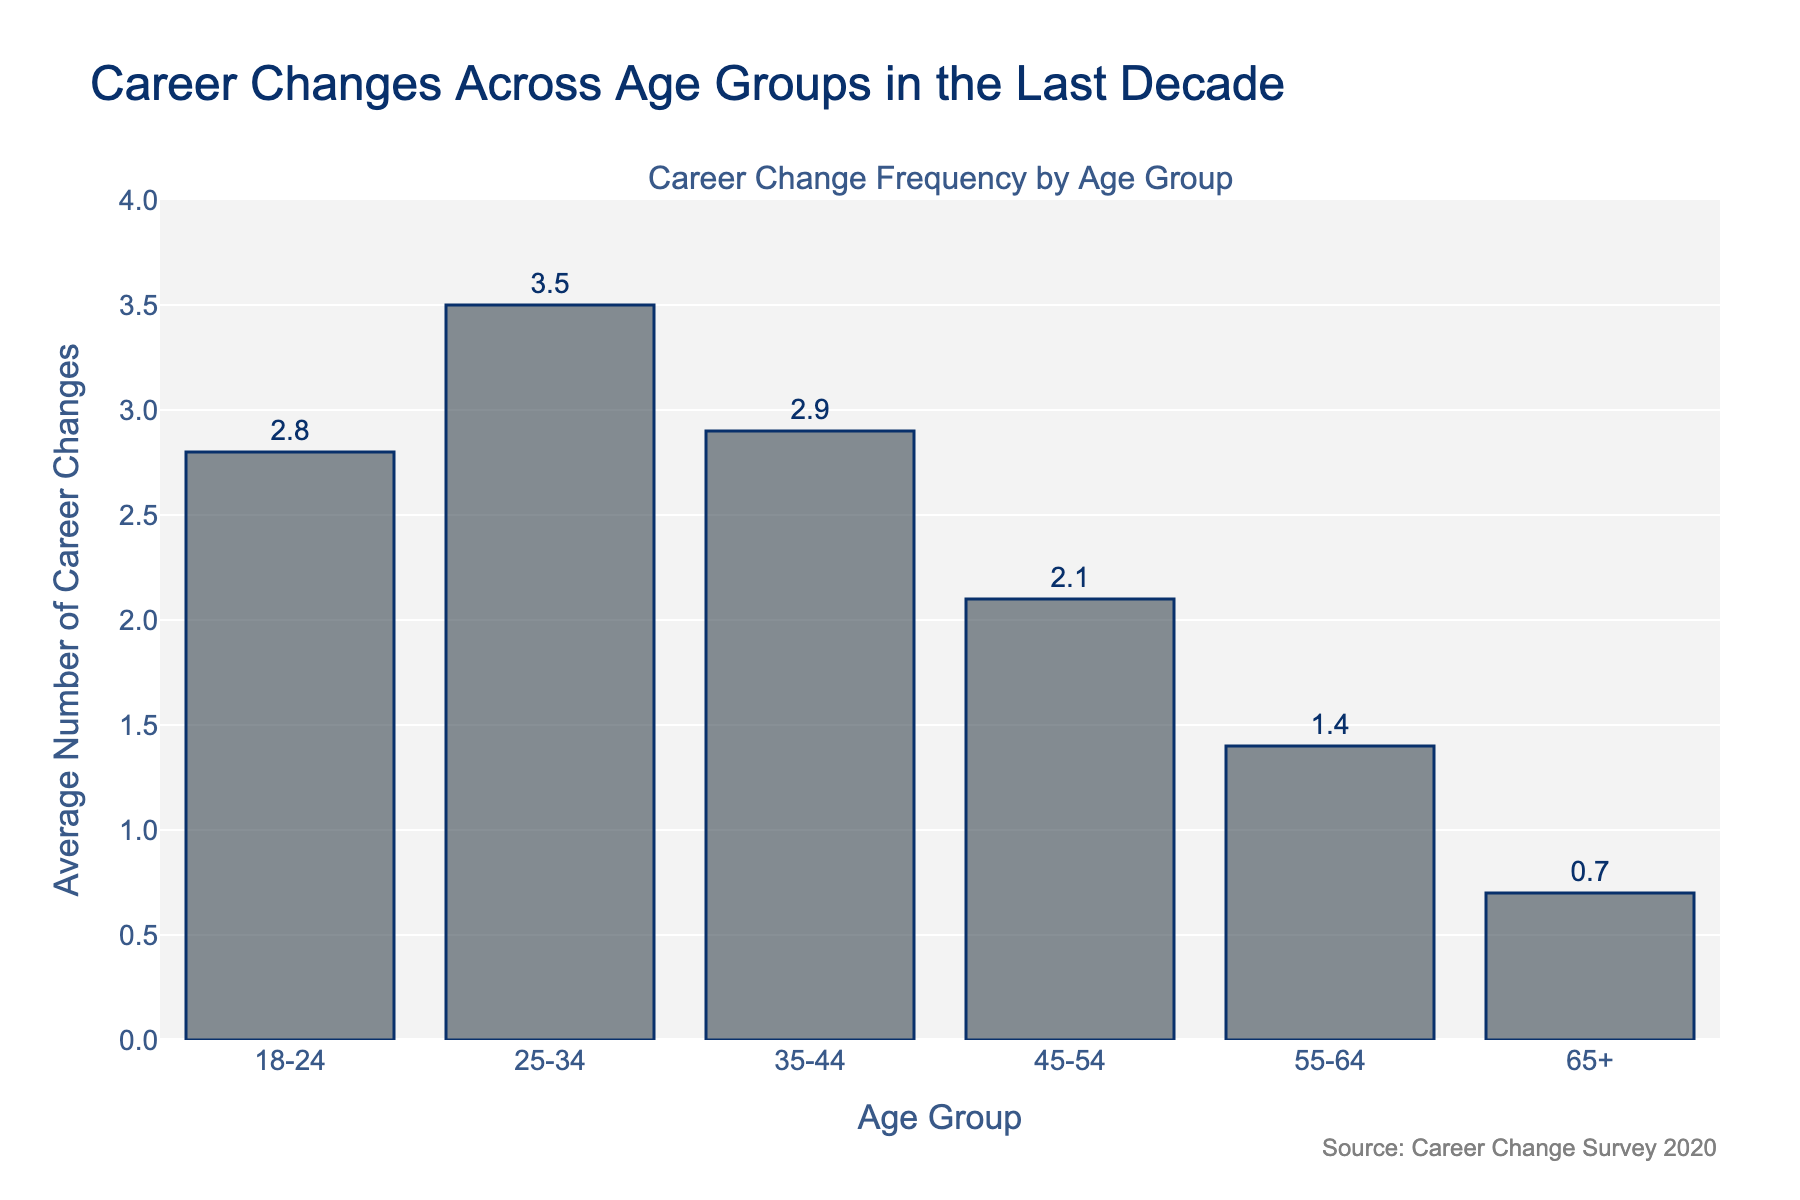What age group has the highest average number of career changes? The age group with the highest bar represents the highest average number of career changes. The height of the bar for age group 25-34 is the highest at 3.5.
Answer: 25-34 Which age group has the lowest average number of career changes? The age group with the shortest bar represents the lowest average number of career changes. The 65+ age group has a bar height of 0.7, which is the shortest.
Answer: 65+ How much more frequent are career changes for the 25-34 age group compared to the 55-64 age group? Subtract the average career changes for the 55-64 age group from the 25-34 age group. For 25-34, the value is 3.5, and for 55-64, the value is 1.4. Thus, the difference is 3.5 - 1.4 = 2.1.
Answer: 2.1 What is the total number of career changes for age groups under 35? Add the average career changes for the 18-24 and 25-34 age groups. The values are 2.8 and 3.5 respectively. So, the total is 2.8 + 3.5 = 6.3.
Answer: 6.3 Which age group has nearly the same average career changes as the 18-24 age group? Compare the average values of other age groups with 18-24, which has 2.8 average changes. The 35-44 age group has 2.9 average changes, which is close to 2.8.
Answer: 35-44 What is the difference in the average career changes between the 45-54 and the 55-64 age groups? Subtract the average career changes for the 55-64 age group from the 45-54 age group. The values are 2.1 for 45-54 and 1.4 for 55-64. So, 2.1 - 1.4 = 0.7.
Answer: 0.7 What is the average career changes across all age groups in the dataset? Sum all the values and divide by the number of age groups. The sum is 2.8 + 3.5 + 2.9 + 2.1 + 1.4 + 0.7 = 13.4. There are 6 age groups, so the average is 13.4 / 6 = 2.23.
Answer: 2.23 Between which two consecutive age groups does the largest decrease in career changes occur? Calculate the difference between each pair of consecutive age groups and find the largest decrease. The differences are: (2.8 - 3.5 = -0.7), (3.5 - 2.9 = 0.6), (2.9 - 2.1 = 0.8), (2.1 - 1.4 = 0.7), (1.4 - 0.7 = 0.7). The largest decrease (-0.7) occurs between 18-24 and 25-34.
Answer: 18-24 to 25-34 What is the median value of average career changes by age group? Order the values and find the median. The ordered values are 0.7, 1.4, 2.1, 2.8, 2.9, 3.5. The middle values are 2.1 and 2.8, so the median is (2.1 + 2.8) / 2 = 2.45.
Answer: 2.45 